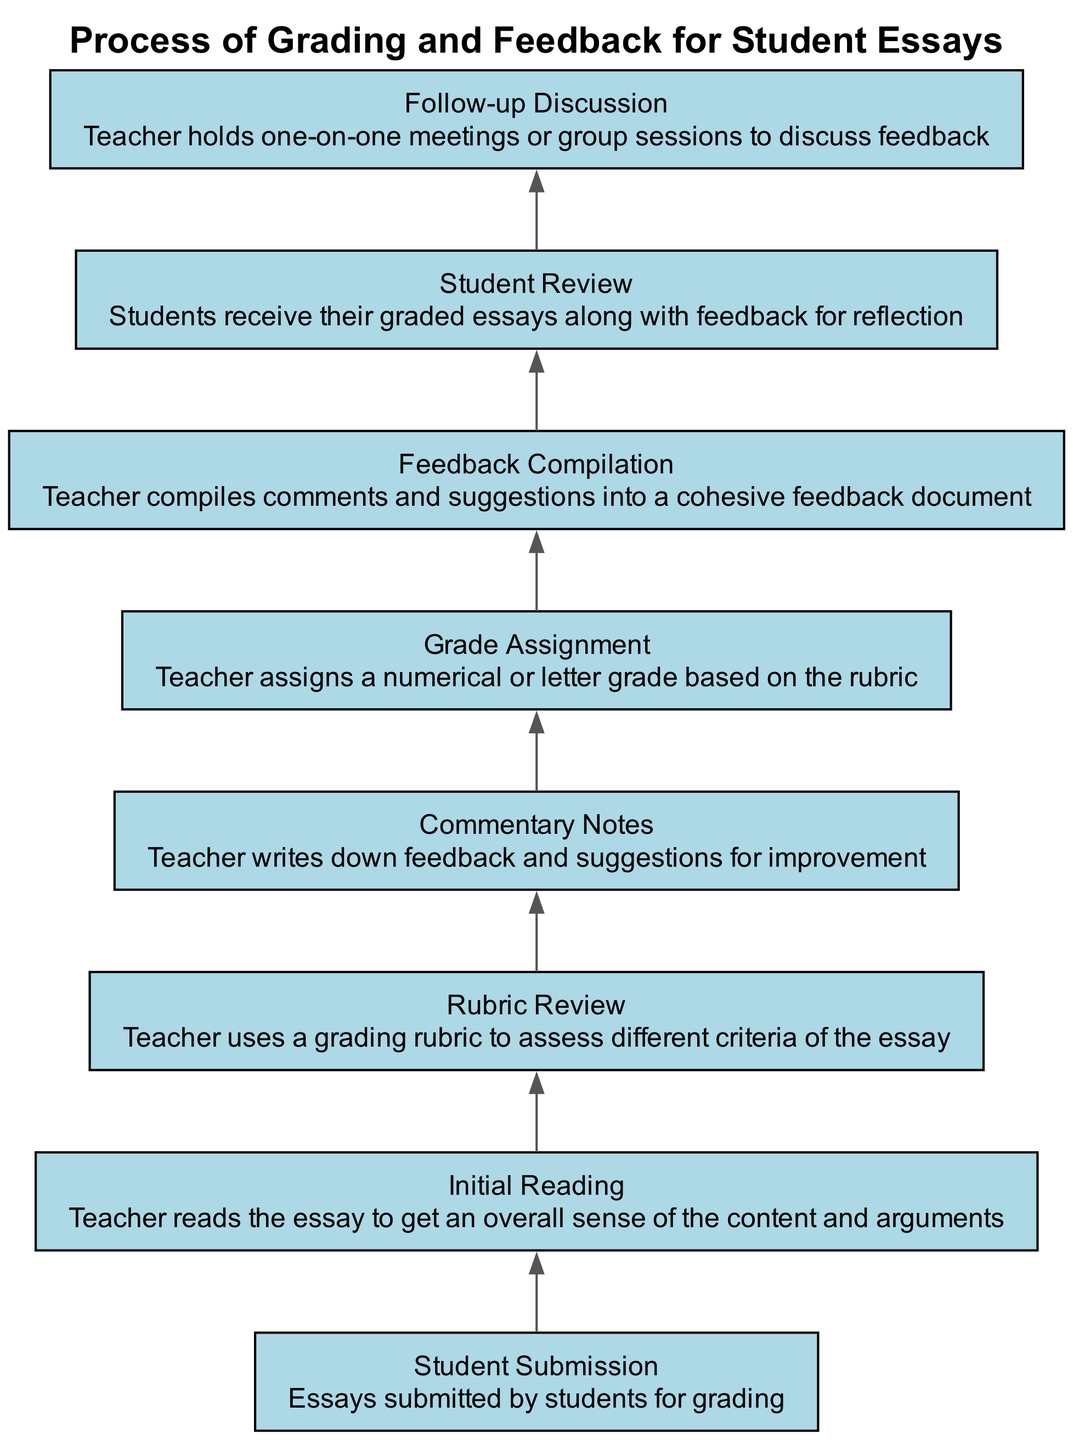What is the first step in the grading process? The first step in the diagram is "Student Submission," which indicates that the process begins with essays submitted by students.
Answer: Student Submission How many nodes are in the flow chart? By counting all the elements listed in the diagram, there are eight distinct nodes outlining the grading process.
Answer: 8 What comes immediately after the "Initial Reading"? Following "Initial Reading," the next step noted in the flow chart is "Rubric Review," which indicates that the teacher refers to the grading rubric next.
Answer: Rubric Review Which node involves assigning a grade? The node labeled "Grade Assignment" specifically notes the step where a numerical or letter grade is assigned based on the rubric evaluation.
Answer: Grade Assignment What is the final step in the feedback process? The last step shown in the diagram is "Follow-up Discussion," emphasizing the importance of discussing the feedback with students.
Answer: Follow-up Discussion How does "Feedback Compilation" relate to "Commentary Notes"? "Feedback Compilation" follows "Commentary Notes," indicating that feedback from commentary notes is gathered and compiled into a cohesive document.
Answer: Feedback Compilation What is the relationship between "Student Review" and "Follow-up Discussion"? "Student Review" precedes "Follow-up Discussion," which suggests that students first review their feedback before discussing it further in meetings.
Answer: Student Review What action is taken after "Grade Assignment"? After "Grade Assignment," the next action taken is "Feedback Compilation," where the teacher compiles the feedback given into a document.
Answer: Feedback Compilation What type of feedback is noted in "Commentary Notes"? The "Commentary Notes" involves writing down feedback and suggestions for improvement, which plays a critical role in the overall grading process.
Answer: Feedback and suggestions for improvement 